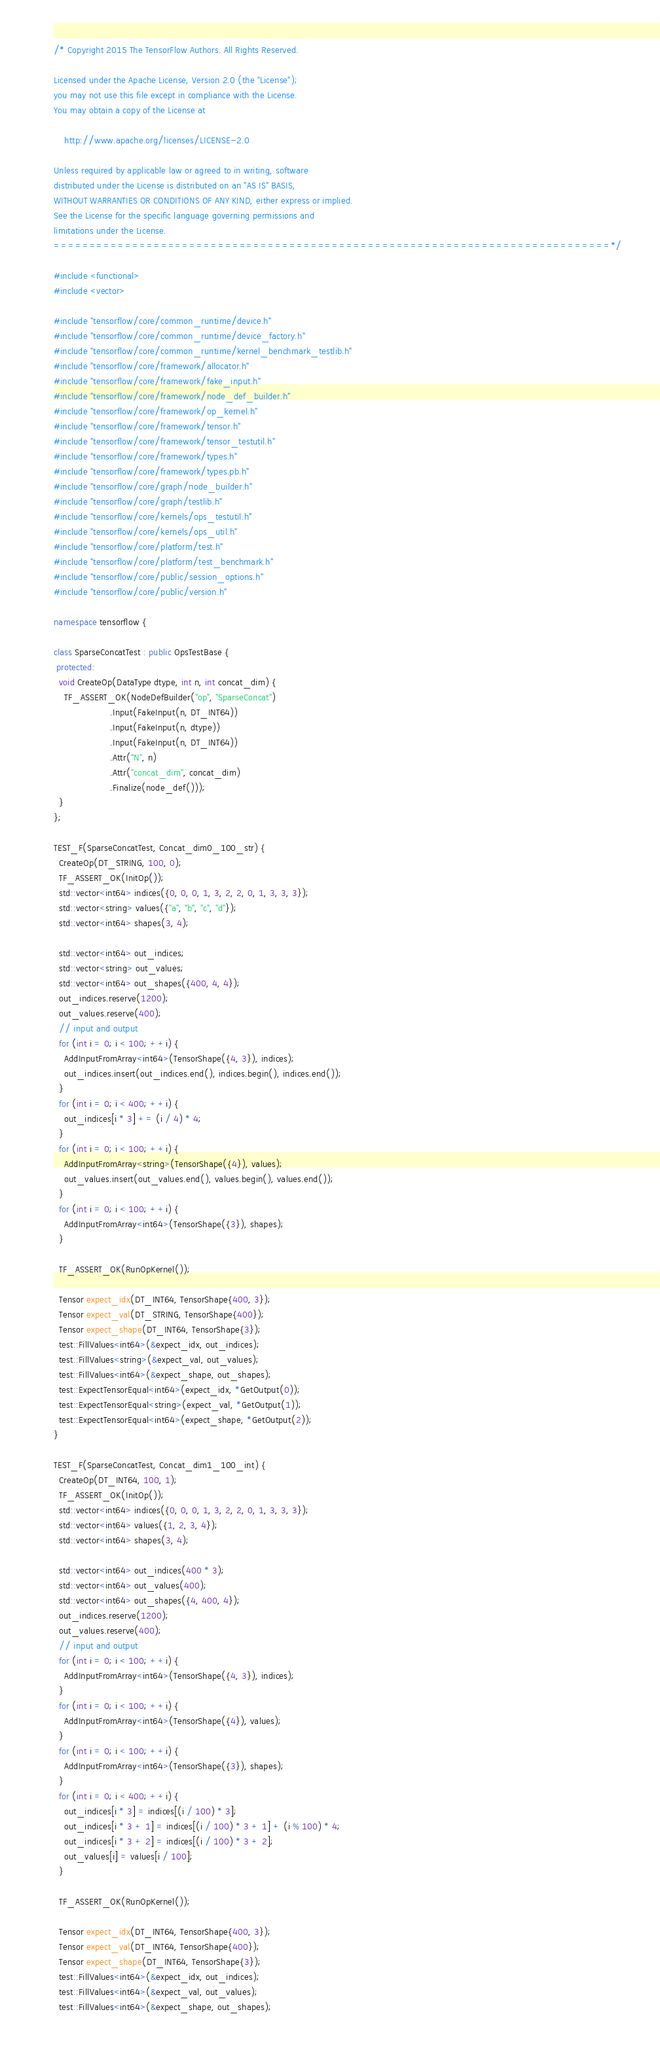Convert code to text. <code><loc_0><loc_0><loc_500><loc_500><_C++_>/* Copyright 2015 The TensorFlow Authors. All Rights Reserved.

Licensed under the Apache License, Version 2.0 (the "License");
you may not use this file except in compliance with the License.
You may obtain a copy of the License at

    http://www.apache.org/licenses/LICENSE-2.0

Unless required by applicable law or agreed to in writing, software
distributed under the License is distributed on an "AS IS" BASIS,
WITHOUT WARRANTIES OR CONDITIONS OF ANY KIND, either express or implied.
See the License for the specific language governing permissions and
limitations under the License.
==============================================================================*/

#include <functional>
#include <vector>

#include "tensorflow/core/common_runtime/device.h"
#include "tensorflow/core/common_runtime/device_factory.h"
#include "tensorflow/core/common_runtime/kernel_benchmark_testlib.h"
#include "tensorflow/core/framework/allocator.h"
#include "tensorflow/core/framework/fake_input.h"
#include "tensorflow/core/framework/node_def_builder.h"
#include "tensorflow/core/framework/op_kernel.h"
#include "tensorflow/core/framework/tensor.h"
#include "tensorflow/core/framework/tensor_testutil.h"
#include "tensorflow/core/framework/types.h"
#include "tensorflow/core/framework/types.pb.h"
#include "tensorflow/core/graph/node_builder.h"
#include "tensorflow/core/graph/testlib.h"
#include "tensorflow/core/kernels/ops_testutil.h"
#include "tensorflow/core/kernels/ops_util.h"
#include "tensorflow/core/platform/test.h"
#include "tensorflow/core/platform/test_benchmark.h"
#include "tensorflow/core/public/session_options.h"
#include "tensorflow/core/public/version.h"

namespace tensorflow {

class SparseConcatTest : public OpsTestBase {
 protected:
  void CreateOp(DataType dtype, int n, int concat_dim) {
    TF_ASSERT_OK(NodeDefBuilder("op", "SparseConcat")
                     .Input(FakeInput(n, DT_INT64))
                     .Input(FakeInput(n, dtype))
                     .Input(FakeInput(n, DT_INT64))
                     .Attr("N", n)
                     .Attr("concat_dim", concat_dim)
                     .Finalize(node_def()));
  }
};

TEST_F(SparseConcatTest, Concat_dim0_100_str) {
  CreateOp(DT_STRING, 100, 0);
  TF_ASSERT_OK(InitOp());
  std::vector<int64> indices({0, 0, 0, 1, 3, 2, 2, 0, 1, 3, 3, 3});
  std::vector<string> values({"a", "b", "c", "d"});
  std::vector<int64> shapes(3, 4);

  std::vector<int64> out_indices;
  std::vector<string> out_values;
  std::vector<int64> out_shapes({400, 4, 4});
  out_indices.reserve(1200);
  out_values.reserve(400);
  // input and output
  for (int i = 0; i < 100; ++i) {
    AddInputFromArray<int64>(TensorShape({4, 3}), indices);
    out_indices.insert(out_indices.end(), indices.begin(), indices.end());
  }
  for (int i = 0; i < 400; ++i) {
    out_indices[i * 3] += (i / 4) * 4;
  }
  for (int i = 0; i < 100; ++i) {
    AddInputFromArray<string>(TensorShape({4}), values);
    out_values.insert(out_values.end(), values.begin(), values.end());
  }
  for (int i = 0; i < 100; ++i) {
    AddInputFromArray<int64>(TensorShape({3}), shapes);
  }

  TF_ASSERT_OK(RunOpKernel());

  Tensor expect_idx(DT_INT64, TensorShape{400, 3});
  Tensor expect_val(DT_STRING, TensorShape{400});
  Tensor expect_shape(DT_INT64, TensorShape{3});
  test::FillValues<int64>(&expect_idx, out_indices);
  test::FillValues<string>(&expect_val, out_values);
  test::FillValues<int64>(&expect_shape, out_shapes);
  test::ExpectTensorEqual<int64>(expect_idx, *GetOutput(0));
  test::ExpectTensorEqual<string>(expect_val, *GetOutput(1));
  test::ExpectTensorEqual<int64>(expect_shape, *GetOutput(2));
}

TEST_F(SparseConcatTest, Concat_dim1_100_int) {
  CreateOp(DT_INT64, 100, 1);
  TF_ASSERT_OK(InitOp());
  std::vector<int64> indices({0, 0, 0, 1, 3, 2, 2, 0, 1, 3, 3, 3});
  std::vector<int64> values({1, 2, 3, 4});
  std::vector<int64> shapes(3, 4);

  std::vector<int64> out_indices(400 * 3);
  std::vector<int64> out_values(400);
  std::vector<int64> out_shapes({4, 400, 4});
  out_indices.reserve(1200);
  out_values.reserve(400);
  // input and output
  for (int i = 0; i < 100; ++i) {
    AddInputFromArray<int64>(TensorShape({4, 3}), indices);
  }
  for (int i = 0; i < 100; ++i) {
    AddInputFromArray<int64>(TensorShape({4}), values);
  }
  for (int i = 0; i < 100; ++i) {
    AddInputFromArray<int64>(TensorShape({3}), shapes);
  }
  for (int i = 0; i < 400; ++i) {
    out_indices[i * 3] = indices[(i / 100) * 3];
    out_indices[i * 3 + 1] = indices[(i / 100) * 3 + 1] + (i % 100) * 4;
    out_indices[i * 3 + 2] = indices[(i / 100) * 3 + 2];
    out_values[i] = values[i / 100];
  }

  TF_ASSERT_OK(RunOpKernel());

  Tensor expect_idx(DT_INT64, TensorShape{400, 3});
  Tensor expect_val(DT_INT64, TensorShape{400});
  Tensor expect_shape(DT_INT64, TensorShape{3});
  test::FillValues<int64>(&expect_idx, out_indices);
  test::FillValues<int64>(&expect_val, out_values);
  test::FillValues<int64>(&expect_shape, out_shapes);</code> 